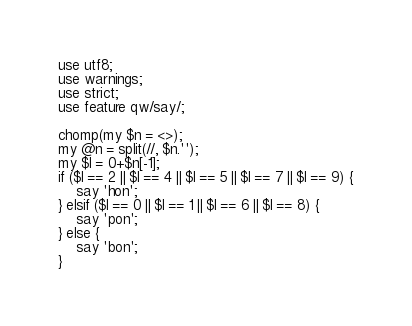<code> <loc_0><loc_0><loc_500><loc_500><_Perl_>use utf8;
use warnings;
use strict;
use feature qw/say/;

chomp(my $n = <>);
my @n = split(//, $n.'');
my $l = 0+$n[-1];
if ($l == 2 || $l == 4 || $l == 5 || $l == 7 || $l == 9) {
    say 'hon';
} elsif ($l == 0 || $l == 1 || $l == 6 || $l == 8) {
    say 'pon';
} else {
    say 'bon';
}</code> 